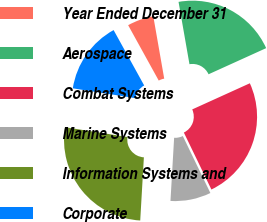Convert chart to OTSL. <chart><loc_0><loc_0><loc_500><loc_500><pie_chart><fcel>Year Ended December 31<fcel>Aerospace<fcel>Combat Systems<fcel>Marine Systems<fcel>Information Systems and<fcel>Corporate<nl><fcel>5.27%<fcel>20.98%<fcel>24.61%<fcel>8.09%<fcel>26.56%<fcel>14.49%<nl></chart> 